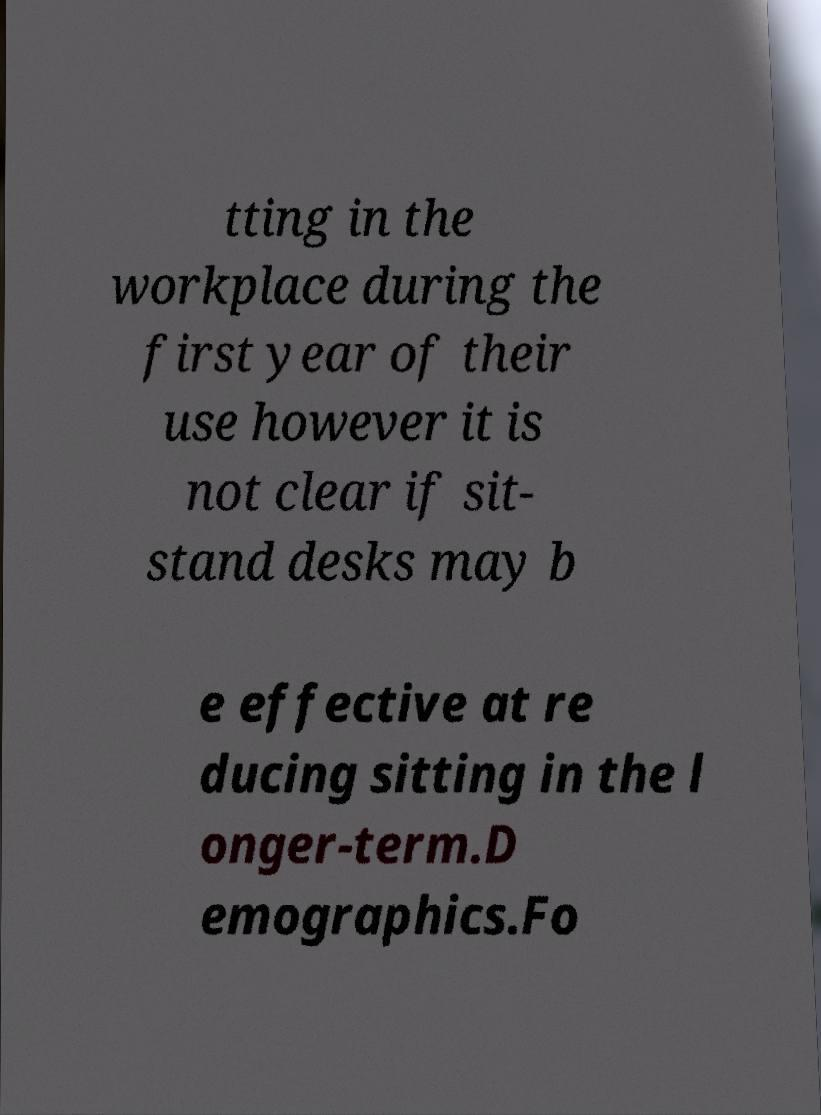There's text embedded in this image that I need extracted. Can you transcribe it verbatim? tting in the workplace during the first year of their use however it is not clear if sit- stand desks may b e effective at re ducing sitting in the l onger-term.D emographics.Fo 